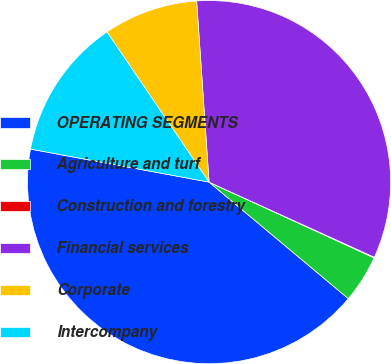Convert chart. <chart><loc_0><loc_0><loc_500><loc_500><pie_chart><fcel>OPERATING SEGMENTS<fcel>Agriculture and turf<fcel>Construction and forestry<fcel>Financial services<fcel>Corporate<fcel>Intercompany<nl><fcel>41.82%<fcel>4.24%<fcel>0.06%<fcel>32.88%<fcel>8.41%<fcel>12.59%<nl></chart> 